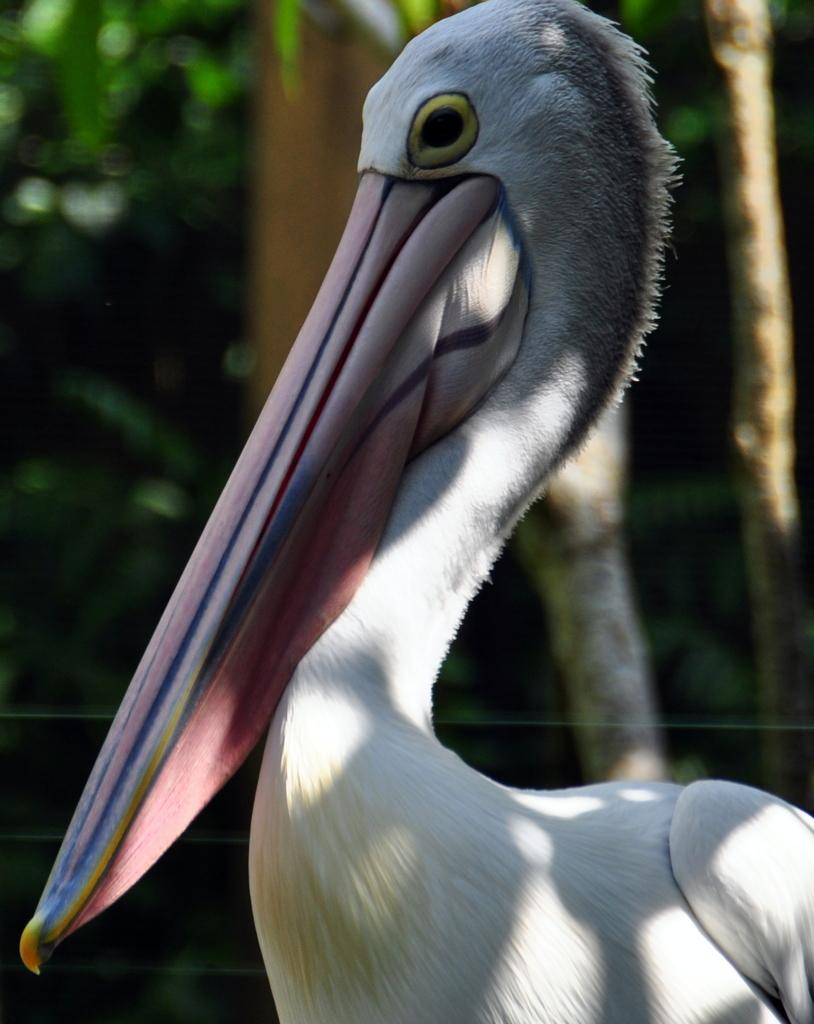What type of animal is in the image? There is a bird in the image. Can you describe the bird's coloring? The bird is white and cream colored. What can be seen in the background of the image? There are trees in the background of the image, but they are blurry. How does the bird express its feelings in the image? The image does not depict the bird expressing any feelings, as it is a still image. 